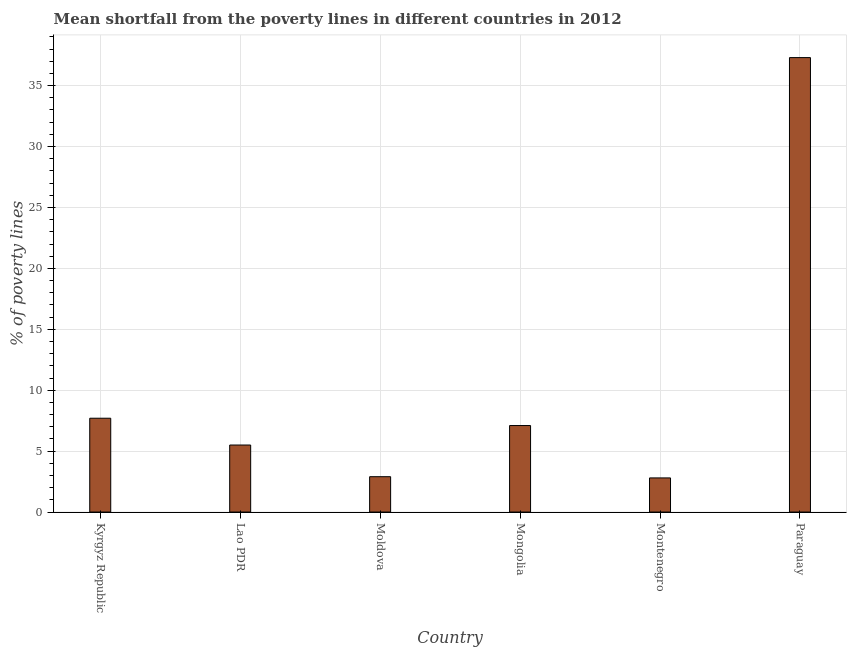What is the title of the graph?
Give a very brief answer. Mean shortfall from the poverty lines in different countries in 2012. What is the label or title of the Y-axis?
Provide a short and direct response. % of poverty lines. What is the poverty gap at national poverty lines in Mongolia?
Keep it short and to the point. 7.1. Across all countries, what is the maximum poverty gap at national poverty lines?
Your answer should be compact. 37.3. In which country was the poverty gap at national poverty lines maximum?
Make the answer very short. Paraguay. In which country was the poverty gap at national poverty lines minimum?
Provide a short and direct response. Montenegro. What is the sum of the poverty gap at national poverty lines?
Offer a very short reply. 63.3. What is the average poverty gap at national poverty lines per country?
Offer a very short reply. 10.55. What is the median poverty gap at national poverty lines?
Provide a short and direct response. 6.3. In how many countries, is the poverty gap at national poverty lines greater than 9 %?
Give a very brief answer. 1. What is the ratio of the poverty gap at national poverty lines in Moldova to that in Paraguay?
Your response must be concise. 0.08. What is the difference between the highest and the second highest poverty gap at national poverty lines?
Give a very brief answer. 29.6. What is the difference between the highest and the lowest poverty gap at national poverty lines?
Provide a succinct answer. 34.5. What is the difference between two consecutive major ticks on the Y-axis?
Provide a short and direct response. 5. What is the % of poverty lines in Kyrgyz Republic?
Provide a succinct answer. 7.7. What is the % of poverty lines in Mongolia?
Ensure brevity in your answer.  7.1. What is the % of poverty lines in Paraguay?
Offer a terse response. 37.3. What is the difference between the % of poverty lines in Kyrgyz Republic and Lao PDR?
Provide a succinct answer. 2.2. What is the difference between the % of poverty lines in Kyrgyz Republic and Moldova?
Make the answer very short. 4.8. What is the difference between the % of poverty lines in Kyrgyz Republic and Mongolia?
Your answer should be compact. 0.6. What is the difference between the % of poverty lines in Kyrgyz Republic and Paraguay?
Your response must be concise. -29.6. What is the difference between the % of poverty lines in Lao PDR and Mongolia?
Make the answer very short. -1.6. What is the difference between the % of poverty lines in Lao PDR and Paraguay?
Keep it short and to the point. -31.8. What is the difference between the % of poverty lines in Moldova and Mongolia?
Provide a succinct answer. -4.2. What is the difference between the % of poverty lines in Moldova and Paraguay?
Make the answer very short. -34.4. What is the difference between the % of poverty lines in Mongolia and Paraguay?
Provide a short and direct response. -30.2. What is the difference between the % of poverty lines in Montenegro and Paraguay?
Keep it short and to the point. -34.5. What is the ratio of the % of poverty lines in Kyrgyz Republic to that in Lao PDR?
Offer a very short reply. 1.4. What is the ratio of the % of poverty lines in Kyrgyz Republic to that in Moldova?
Provide a short and direct response. 2.65. What is the ratio of the % of poverty lines in Kyrgyz Republic to that in Mongolia?
Provide a short and direct response. 1.08. What is the ratio of the % of poverty lines in Kyrgyz Republic to that in Montenegro?
Your answer should be very brief. 2.75. What is the ratio of the % of poverty lines in Kyrgyz Republic to that in Paraguay?
Make the answer very short. 0.21. What is the ratio of the % of poverty lines in Lao PDR to that in Moldova?
Your response must be concise. 1.9. What is the ratio of the % of poverty lines in Lao PDR to that in Mongolia?
Give a very brief answer. 0.78. What is the ratio of the % of poverty lines in Lao PDR to that in Montenegro?
Your response must be concise. 1.96. What is the ratio of the % of poverty lines in Lao PDR to that in Paraguay?
Offer a very short reply. 0.15. What is the ratio of the % of poverty lines in Moldova to that in Mongolia?
Provide a short and direct response. 0.41. What is the ratio of the % of poverty lines in Moldova to that in Montenegro?
Provide a succinct answer. 1.04. What is the ratio of the % of poverty lines in Moldova to that in Paraguay?
Your answer should be very brief. 0.08. What is the ratio of the % of poverty lines in Mongolia to that in Montenegro?
Make the answer very short. 2.54. What is the ratio of the % of poverty lines in Mongolia to that in Paraguay?
Your answer should be very brief. 0.19. What is the ratio of the % of poverty lines in Montenegro to that in Paraguay?
Keep it short and to the point. 0.07. 